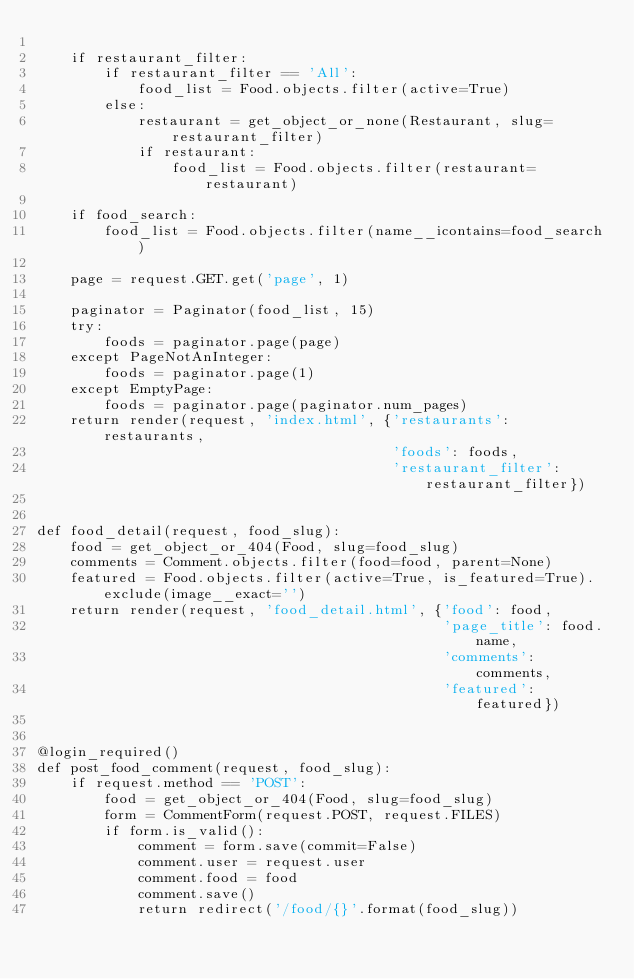Convert code to text. <code><loc_0><loc_0><loc_500><loc_500><_Python_>
    if restaurant_filter:
        if restaurant_filter == 'All':
            food_list = Food.objects.filter(active=True)
        else:
            restaurant = get_object_or_none(Restaurant, slug=restaurant_filter)
            if restaurant:
                food_list = Food.objects.filter(restaurant=restaurant)

    if food_search:
        food_list = Food.objects.filter(name__icontains=food_search)

    page = request.GET.get('page', 1)

    paginator = Paginator(food_list, 15)
    try:
        foods = paginator.page(page)
    except PageNotAnInteger:
        foods = paginator.page(1)
    except EmptyPage:
        foods = paginator.page(paginator.num_pages)
    return render(request, 'index.html', {'restaurants': restaurants,
                                          'foods': foods,
                                          'restaurant_filter': restaurant_filter})


def food_detail(request, food_slug):
    food = get_object_or_404(Food, slug=food_slug)
    comments = Comment.objects.filter(food=food, parent=None)
    featured = Food.objects.filter(active=True, is_featured=True).exclude(image__exact='')
    return render(request, 'food_detail.html', {'food': food,
                                                'page_title': food.name,
                                                'comments': comments,
                                                'featured': featured})


@login_required()
def post_food_comment(request, food_slug):
    if request.method == 'POST':
        food = get_object_or_404(Food, slug=food_slug)
        form = CommentForm(request.POST, request.FILES)
        if form.is_valid():
            comment = form.save(commit=False)
            comment.user = request.user
            comment.food = food
            comment.save()
            return redirect('/food/{}'.format(food_slug))
</code> 